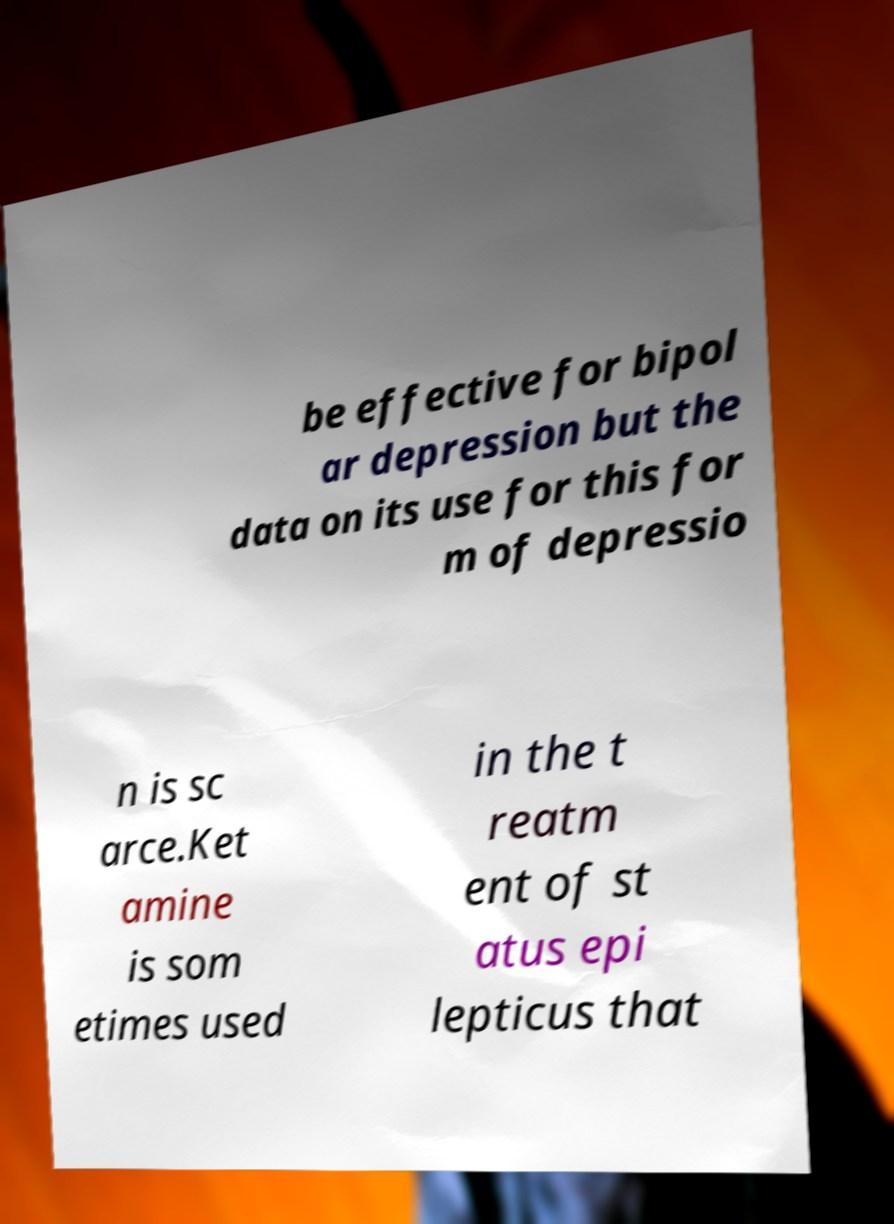Can you read and provide the text displayed in the image?This photo seems to have some interesting text. Can you extract and type it out for me? be effective for bipol ar depression but the data on its use for this for m of depressio n is sc arce.Ket amine is som etimes used in the t reatm ent of st atus epi lepticus that 